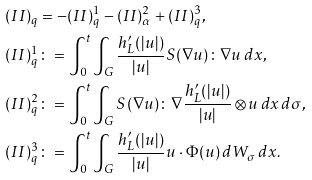Convert formula to latex. <formula><loc_0><loc_0><loc_500><loc_500>( I I ) _ { q } & = - ( I I ) ^ { 1 } _ { q } - ( I I ) ^ { 2 } _ { \alpha } + ( I I ) ^ { 3 } _ { q } , \\ ( I I ) _ { q } ^ { 1 } & \colon = \int _ { 0 } ^ { t } \int _ { G } \frac { h _ { L } ^ { \prime } ( | u | ) } { | u | } S ( \nabla u ) \colon \nabla u \, d x , \\ ( I I ) _ { q } ^ { 2 } & \colon = \int _ { 0 } ^ { t } \int _ { G } S ( \nabla u ) \colon \nabla \frac { h _ { L } ^ { \prime } ( | u | ) } { | u | } \otimes u \, d x \, d \sigma , \\ ( I I ) _ { q } ^ { 3 } & \colon = \int _ { 0 } ^ { t } \int _ { G } \frac { h _ { L } ^ { \prime } ( | u | ) } { | u | } u \cdot \Phi ( u ) \, d W _ { \sigma } \, d x .</formula> 